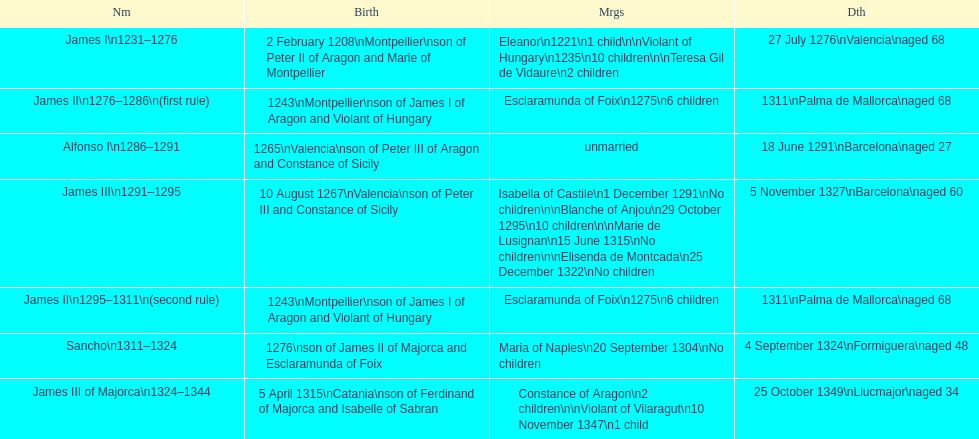Which king or queen had the most nuptials? James III 1291-1295. 